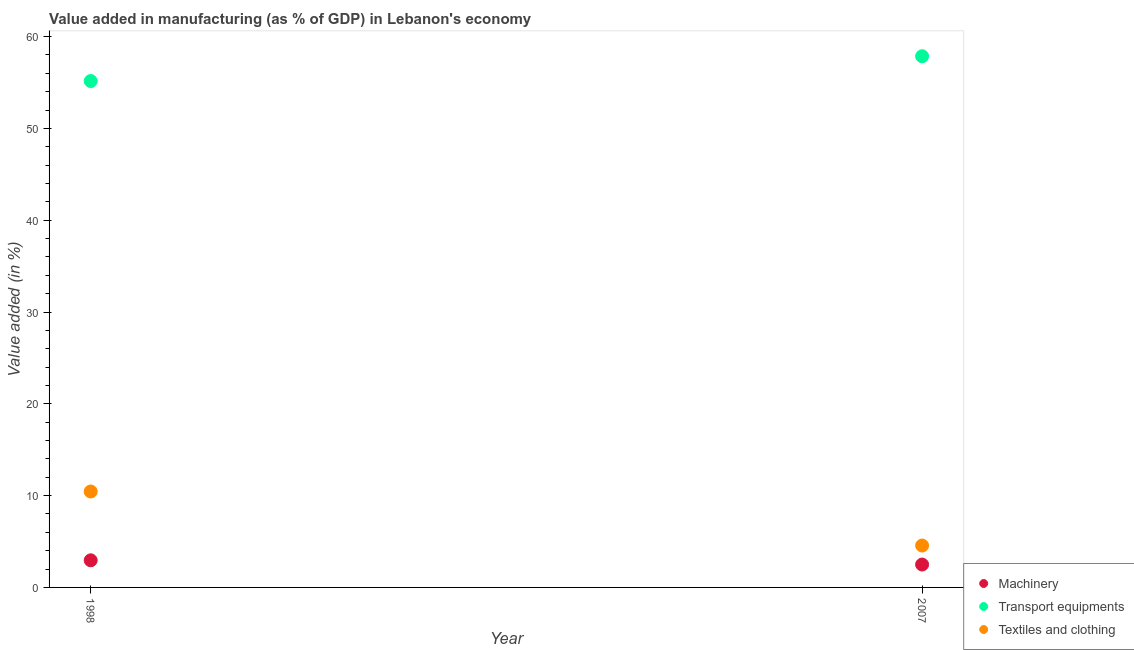What is the value added in manufacturing textile and clothing in 1998?
Provide a short and direct response. 10.45. Across all years, what is the maximum value added in manufacturing machinery?
Your response must be concise. 2.95. Across all years, what is the minimum value added in manufacturing textile and clothing?
Offer a very short reply. 4.56. What is the total value added in manufacturing transport equipments in the graph?
Offer a very short reply. 113.02. What is the difference between the value added in manufacturing textile and clothing in 1998 and that in 2007?
Ensure brevity in your answer.  5.89. What is the difference between the value added in manufacturing machinery in 2007 and the value added in manufacturing textile and clothing in 1998?
Your answer should be very brief. -7.96. What is the average value added in manufacturing machinery per year?
Keep it short and to the point. 2.72. In the year 1998, what is the difference between the value added in manufacturing machinery and value added in manufacturing transport equipments?
Offer a terse response. -52.2. What is the ratio of the value added in manufacturing transport equipments in 1998 to that in 2007?
Your response must be concise. 0.95. Is it the case that in every year, the sum of the value added in manufacturing machinery and value added in manufacturing transport equipments is greater than the value added in manufacturing textile and clothing?
Your answer should be very brief. Yes. Is the value added in manufacturing transport equipments strictly greater than the value added in manufacturing textile and clothing over the years?
Provide a succinct answer. Yes. Is the value added in manufacturing machinery strictly less than the value added in manufacturing textile and clothing over the years?
Make the answer very short. Yes. How many dotlines are there?
Your response must be concise. 3. Does the graph contain grids?
Give a very brief answer. No. How many legend labels are there?
Offer a very short reply. 3. How are the legend labels stacked?
Provide a succinct answer. Vertical. What is the title of the graph?
Offer a very short reply. Value added in manufacturing (as % of GDP) in Lebanon's economy. What is the label or title of the Y-axis?
Your answer should be compact. Value added (in %). What is the Value added (in %) in Machinery in 1998?
Provide a succinct answer. 2.95. What is the Value added (in %) in Transport equipments in 1998?
Keep it short and to the point. 55.16. What is the Value added (in %) in Textiles and clothing in 1998?
Offer a very short reply. 10.45. What is the Value added (in %) in Machinery in 2007?
Offer a very short reply. 2.49. What is the Value added (in %) of Transport equipments in 2007?
Offer a very short reply. 57.86. What is the Value added (in %) of Textiles and clothing in 2007?
Offer a very short reply. 4.56. Across all years, what is the maximum Value added (in %) in Machinery?
Offer a very short reply. 2.95. Across all years, what is the maximum Value added (in %) in Transport equipments?
Offer a very short reply. 57.86. Across all years, what is the maximum Value added (in %) of Textiles and clothing?
Make the answer very short. 10.45. Across all years, what is the minimum Value added (in %) of Machinery?
Provide a succinct answer. 2.49. Across all years, what is the minimum Value added (in %) of Transport equipments?
Keep it short and to the point. 55.16. Across all years, what is the minimum Value added (in %) in Textiles and clothing?
Keep it short and to the point. 4.56. What is the total Value added (in %) in Machinery in the graph?
Your answer should be compact. 5.45. What is the total Value added (in %) in Transport equipments in the graph?
Keep it short and to the point. 113.02. What is the total Value added (in %) in Textiles and clothing in the graph?
Give a very brief answer. 15.01. What is the difference between the Value added (in %) of Machinery in 1998 and that in 2007?
Your response must be concise. 0.46. What is the difference between the Value added (in %) in Transport equipments in 1998 and that in 2007?
Give a very brief answer. -2.7. What is the difference between the Value added (in %) of Textiles and clothing in 1998 and that in 2007?
Your response must be concise. 5.89. What is the difference between the Value added (in %) of Machinery in 1998 and the Value added (in %) of Transport equipments in 2007?
Give a very brief answer. -54.91. What is the difference between the Value added (in %) in Machinery in 1998 and the Value added (in %) in Textiles and clothing in 2007?
Your answer should be compact. -1.61. What is the difference between the Value added (in %) in Transport equipments in 1998 and the Value added (in %) in Textiles and clothing in 2007?
Offer a very short reply. 50.59. What is the average Value added (in %) in Machinery per year?
Your answer should be very brief. 2.72. What is the average Value added (in %) in Transport equipments per year?
Keep it short and to the point. 56.51. What is the average Value added (in %) of Textiles and clothing per year?
Offer a terse response. 7.51. In the year 1998, what is the difference between the Value added (in %) of Machinery and Value added (in %) of Transport equipments?
Ensure brevity in your answer.  -52.2. In the year 1998, what is the difference between the Value added (in %) of Machinery and Value added (in %) of Textiles and clothing?
Provide a short and direct response. -7.5. In the year 1998, what is the difference between the Value added (in %) of Transport equipments and Value added (in %) of Textiles and clothing?
Ensure brevity in your answer.  44.71. In the year 2007, what is the difference between the Value added (in %) of Machinery and Value added (in %) of Transport equipments?
Provide a short and direct response. -55.37. In the year 2007, what is the difference between the Value added (in %) in Machinery and Value added (in %) in Textiles and clothing?
Keep it short and to the point. -2.07. In the year 2007, what is the difference between the Value added (in %) in Transport equipments and Value added (in %) in Textiles and clothing?
Ensure brevity in your answer.  53.3. What is the ratio of the Value added (in %) in Machinery in 1998 to that in 2007?
Offer a very short reply. 1.19. What is the ratio of the Value added (in %) of Transport equipments in 1998 to that in 2007?
Provide a succinct answer. 0.95. What is the ratio of the Value added (in %) in Textiles and clothing in 1998 to that in 2007?
Your answer should be very brief. 2.29. What is the difference between the highest and the second highest Value added (in %) of Machinery?
Give a very brief answer. 0.46. What is the difference between the highest and the second highest Value added (in %) in Transport equipments?
Offer a very short reply. 2.7. What is the difference between the highest and the second highest Value added (in %) of Textiles and clothing?
Ensure brevity in your answer.  5.89. What is the difference between the highest and the lowest Value added (in %) in Machinery?
Your answer should be compact. 0.46. What is the difference between the highest and the lowest Value added (in %) in Transport equipments?
Your answer should be very brief. 2.7. What is the difference between the highest and the lowest Value added (in %) in Textiles and clothing?
Ensure brevity in your answer.  5.89. 